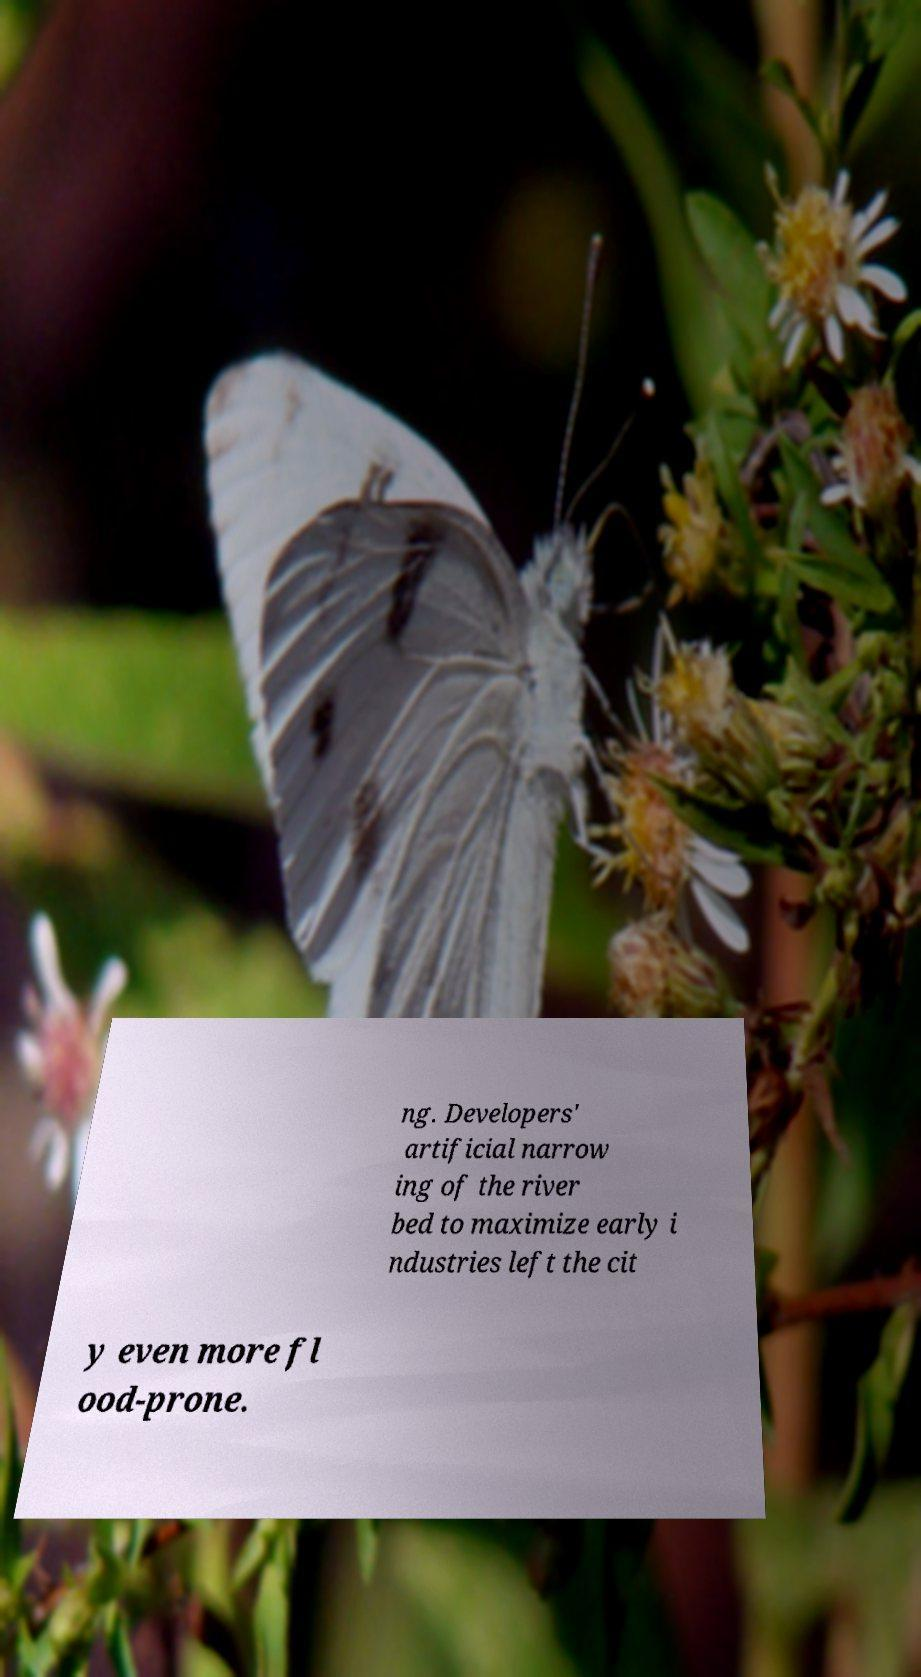Please identify and transcribe the text found in this image. ng. Developers' artificial narrow ing of the river bed to maximize early i ndustries left the cit y even more fl ood-prone. 